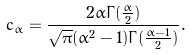<formula> <loc_0><loc_0><loc_500><loc_500>c _ { \alpha } = \frac { 2 \alpha \Gamma { ( \frac { \alpha } { 2 } ) } } { \sqrt { \pi } ( \alpha ^ { 2 } - 1 ) \Gamma { ( \frac { \alpha - 1 } { 2 } ) } } .</formula> 